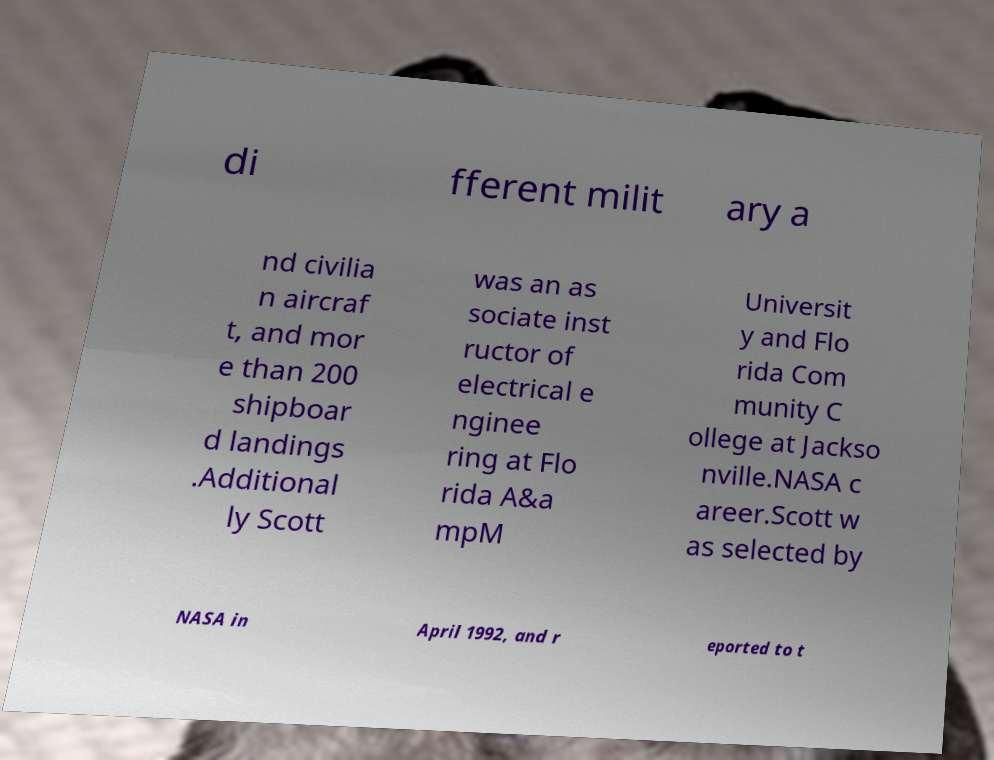Please identify and transcribe the text found in this image. di fferent milit ary a nd civilia n aircraf t, and mor e than 200 shipboar d landings .Additional ly Scott was an as sociate inst ructor of electrical e nginee ring at Flo rida A&a mpM Universit y and Flo rida Com munity C ollege at Jackso nville.NASA c areer.Scott w as selected by NASA in April 1992, and r eported to t 